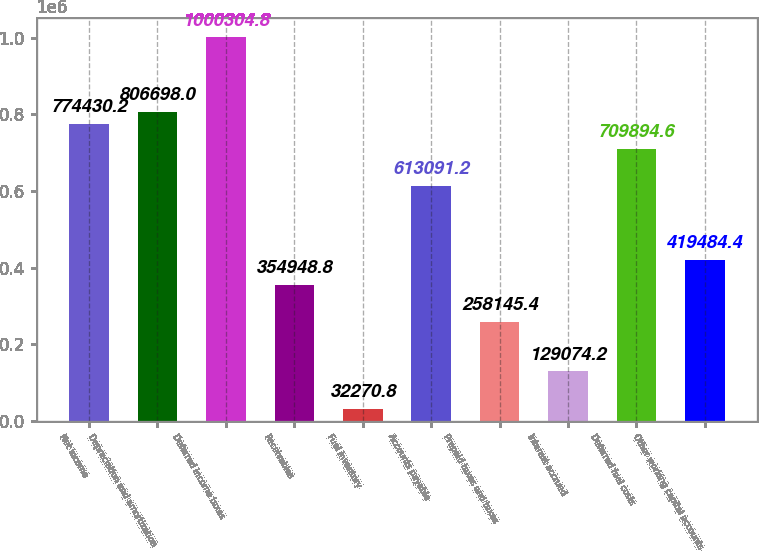Convert chart. <chart><loc_0><loc_0><loc_500><loc_500><bar_chart><fcel>Net income<fcel>Depreciation and amortization<fcel>Deferred income taxes<fcel>Receivables<fcel>Fuel inventory<fcel>Accounts payable<fcel>Prepaid taxes and taxes<fcel>Interest accrued<fcel>Deferred fuel costs<fcel>Other working capital accounts<nl><fcel>774430<fcel>806698<fcel>1.0003e+06<fcel>354949<fcel>32270.8<fcel>613091<fcel>258145<fcel>129074<fcel>709895<fcel>419484<nl></chart> 